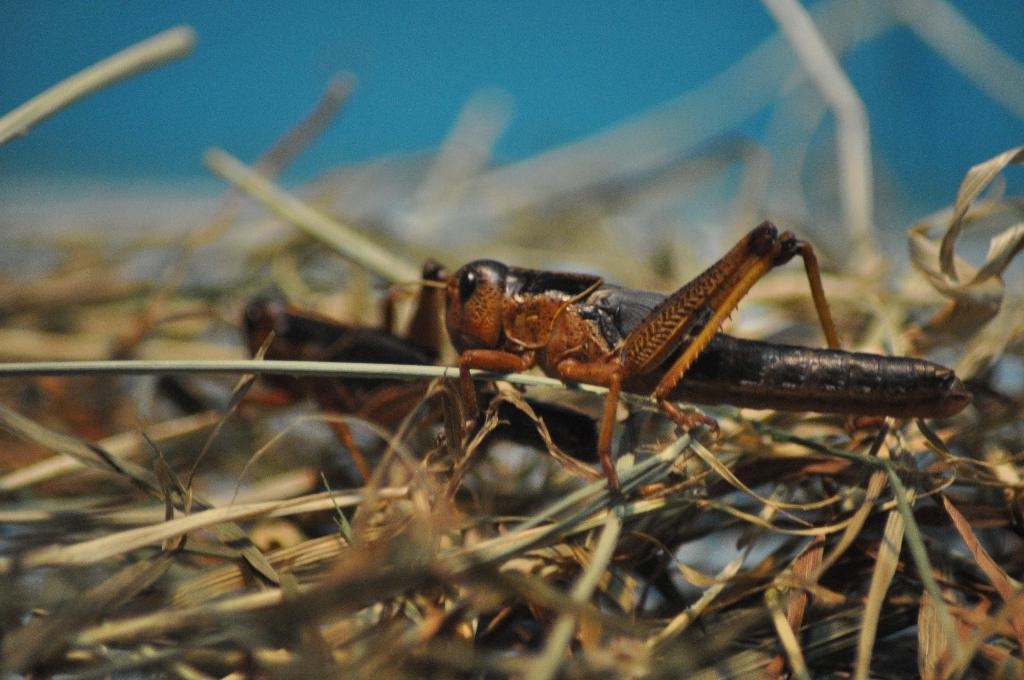What type of living organisms can be seen in the image? There are insects in the image. What natural elements are present in the image? There are dried leaves in the image. Can you describe the background of the image? The background of the image is blurred. How many chairs can be seen in the image? There are no chairs present in the image. What type of building is visible in the background of the image? There is no building visible in the image; the background is blurred. 